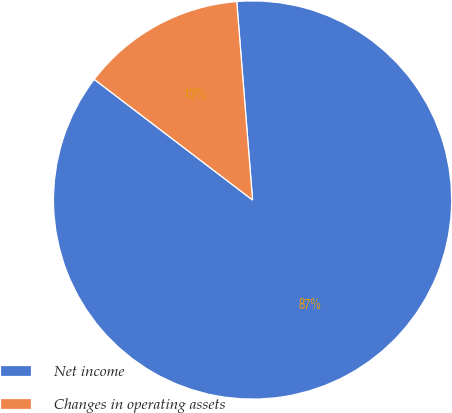Convert chart to OTSL. <chart><loc_0><loc_0><loc_500><loc_500><pie_chart><fcel>Net income<fcel>Changes in operating assets<nl><fcel>86.63%<fcel>13.37%<nl></chart> 